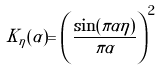Convert formula to latex. <formula><loc_0><loc_0><loc_500><loc_500>K _ { \eta } ( \alpha ) = \left ( \frac { \sin ( \pi \alpha \eta ) } { \pi \alpha } \right ) ^ { 2 }</formula> 